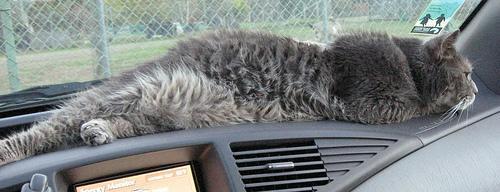How many people are wearing cap?
Give a very brief answer. 0. 